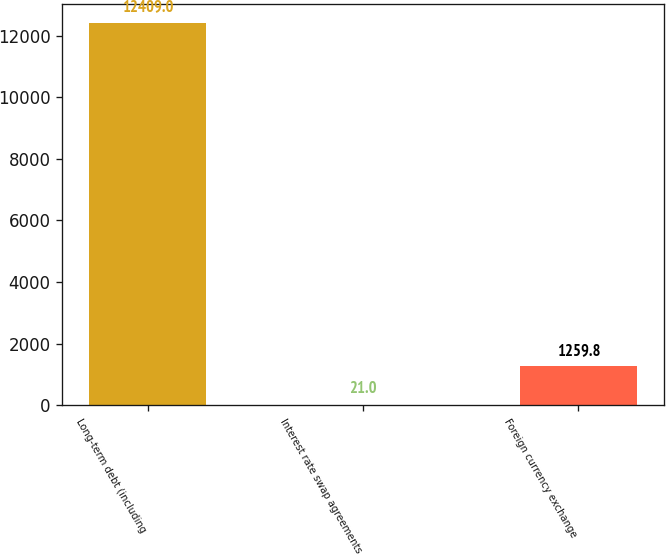Convert chart. <chart><loc_0><loc_0><loc_500><loc_500><bar_chart><fcel>Long-term debt (including<fcel>Interest rate swap agreements<fcel>Foreign currency exchange<nl><fcel>12409<fcel>21<fcel>1259.8<nl></chart> 